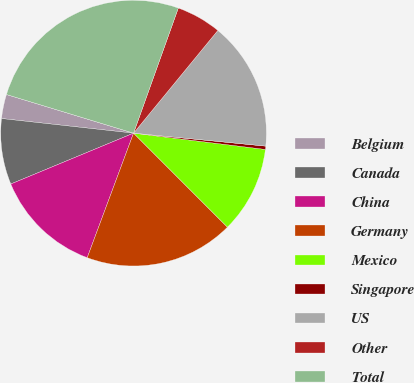Convert chart. <chart><loc_0><loc_0><loc_500><loc_500><pie_chart><fcel>Belgium<fcel>Canada<fcel>China<fcel>Germany<fcel>Mexico<fcel>Singapore<fcel>US<fcel>Other<fcel>Total<nl><fcel>2.94%<fcel>8.01%<fcel>13.08%<fcel>18.16%<fcel>10.55%<fcel>0.4%<fcel>15.62%<fcel>5.47%<fcel>25.77%<nl></chart> 